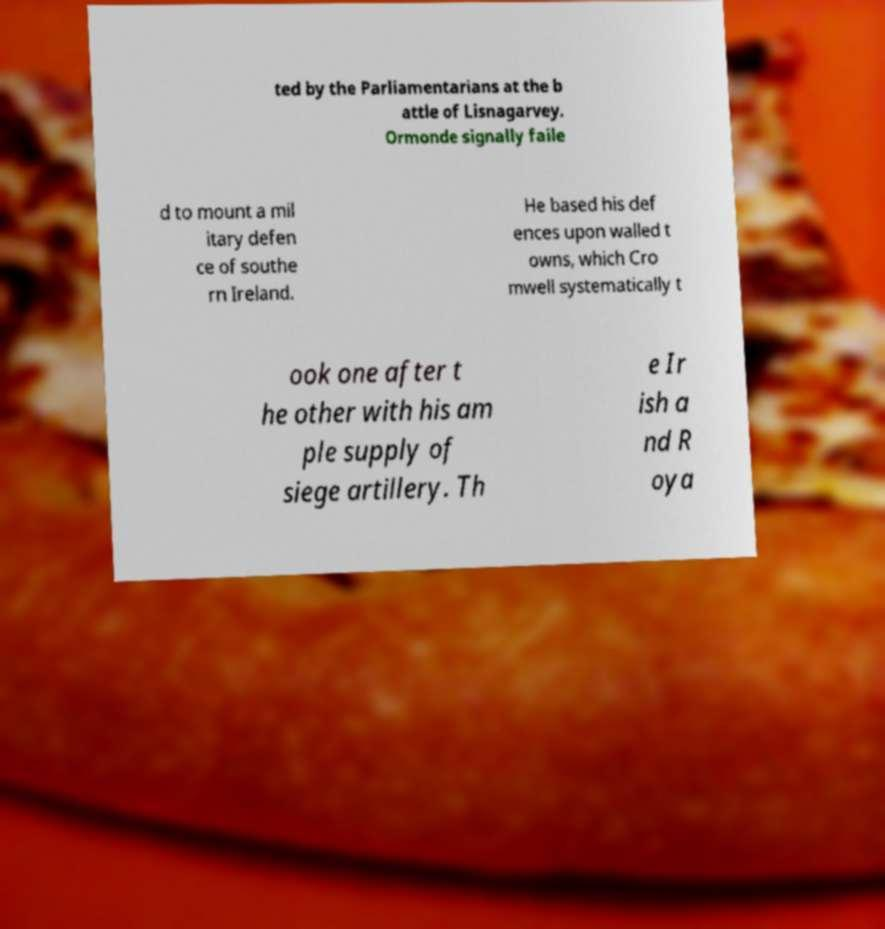Please identify and transcribe the text found in this image. ted by the Parliamentarians at the b attle of Lisnagarvey. Ormonde signally faile d to mount a mil itary defen ce of southe rn Ireland. He based his def ences upon walled t owns, which Cro mwell systematically t ook one after t he other with his am ple supply of siege artillery. Th e Ir ish a nd R oya 